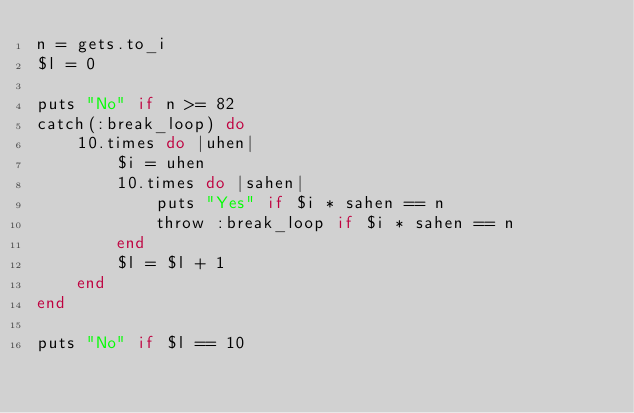<code> <loc_0><loc_0><loc_500><loc_500><_Ruby_>n = gets.to_i
$l = 0

puts "No" if n >= 82
catch(:break_loop) do
    10.times do |uhen|
        $i = uhen
        10.times do |sahen|
            puts "Yes" if $i * sahen == n
            throw :break_loop if $i * sahen == n
        end
        $l = $l + 1
    end
end

puts "No" if $l == 10</code> 